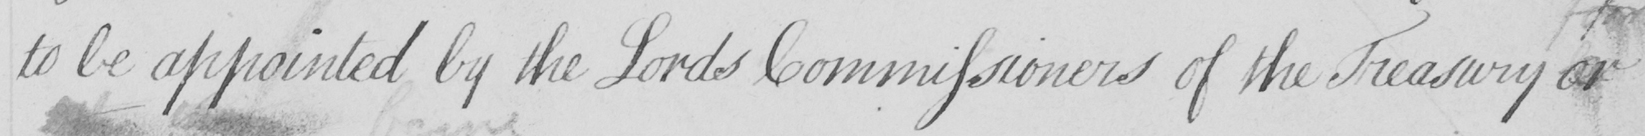Transcribe the text shown in this historical manuscript line. to be appointed by the Lords Commissioners of the Treasury or 